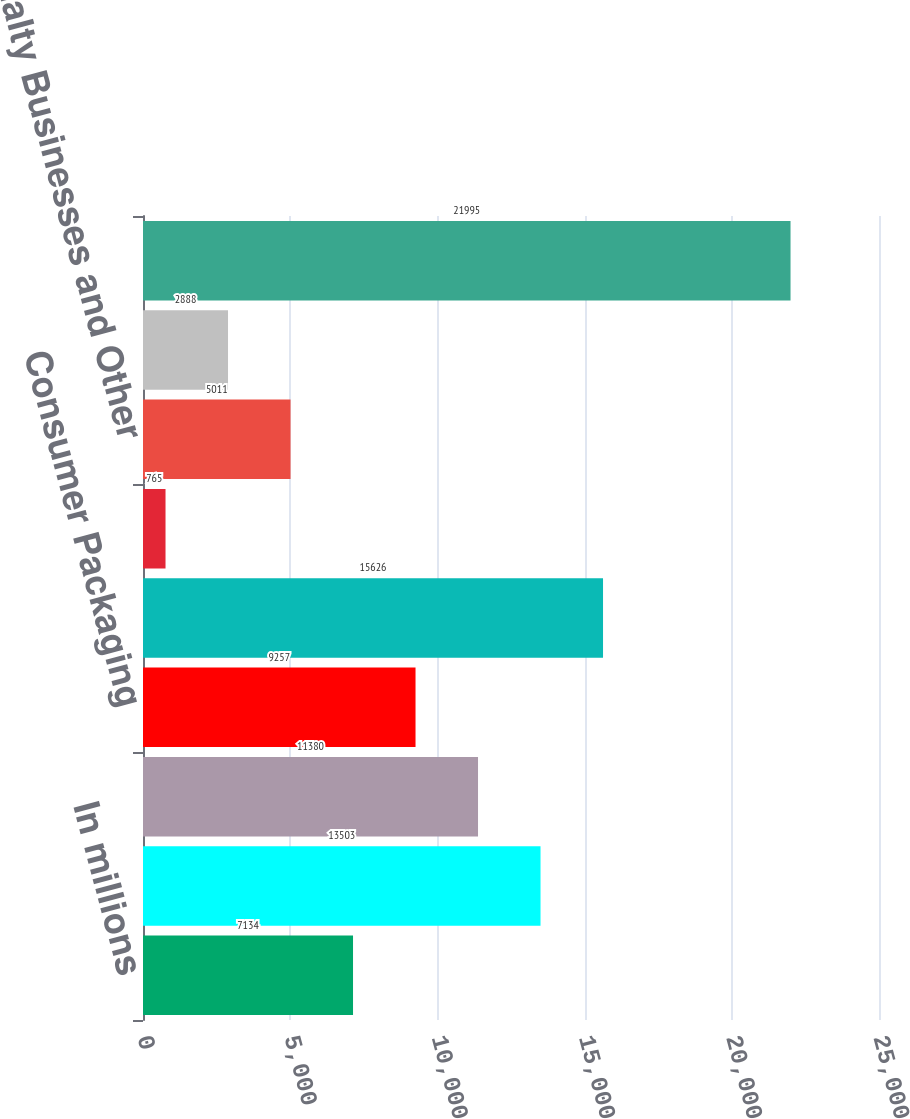Convert chart. <chart><loc_0><loc_0><loc_500><loc_500><bar_chart><fcel>In millions<fcel>Printing Papers<fcel>Industrial Packaging<fcel>Consumer Packaging<fcel>Distribution<fcel>Forest Products<fcel>Specialty Businesses and Other<fcel>Corporate and Intersegment<fcel>Net Sales<nl><fcel>7134<fcel>13503<fcel>11380<fcel>9257<fcel>15626<fcel>765<fcel>5011<fcel>2888<fcel>21995<nl></chart> 